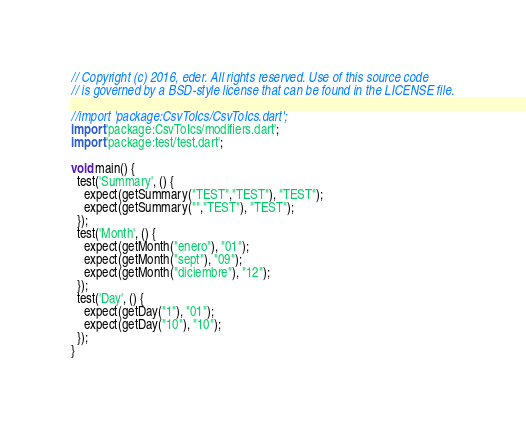<code> <loc_0><loc_0><loc_500><loc_500><_Dart_>// Copyright (c) 2016, eder. All rights reserved. Use of this source code
// is governed by a BSD-style license that can be found in the LICENSE file.

//import 'package:CsvToIcs/CsvToIcs.dart';
import 'package:CsvToIcs/modifiers.dart';
import 'package:test/test.dart';

void main() {
  test('Summary', () {
    expect(getSummary("TEST","TEST"), "TEST");
    expect(getSummary("","TEST"), "TEST");
  });
  test('Month', () {
    expect(getMonth("enero"), "01");
    expect(getMonth("sept"), "09");
    expect(getMonth("diciembre"), "12");
  });
  test('Day', () {
    expect(getDay("1"), "01");
    expect(getDay("10"), "10");
  });
}
</code> 